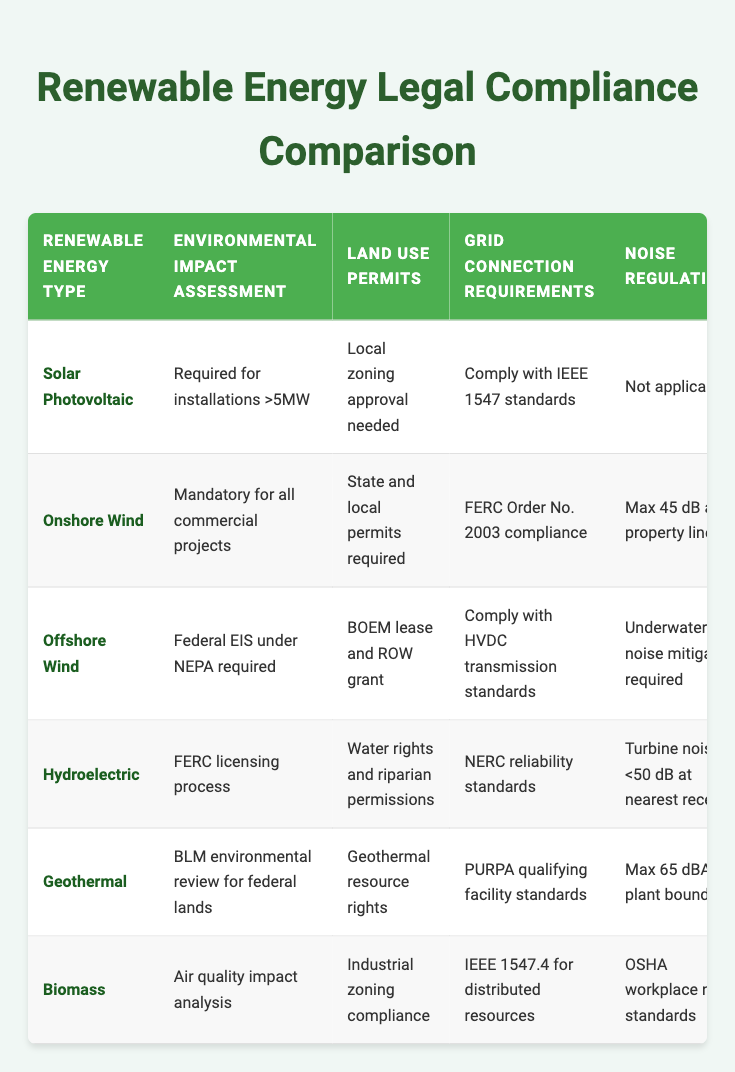What is the environmental impact assessment requirement for offshore wind installations? The table indicates that offshore wind installations require a federal Environmental Impact Statement (EIS) under the National Environmental Policy Act (NEPA).
Answer: Federal EIS under NEPA required Do biomass projects require a visual impact assessment? Looking at the table, biomass projects do require a visual impact assessment, but only for structures that exceed local height limits.
Answer: Yes Which renewable energy type requires a bird-friendly panel design? From the table, it is clear that solar photovoltaic installations are required to incorporate bird-friendly panel design as part of their wildlife protection measures.
Answer: Solar Photovoltaic What are the grid connection requirements for geothermal energy installations? The table shows that geothermal energy installations must comply with the Public Utility Regulatory Policies Act (PURPA) qualifying facility standards as their grid connection requirements.
Answer: PURPA qualifying facility standards Which renewable energy type has the strictest noise regulation? By examining the table, it's observed that onshore wind energy has a maximum allowable noise level of 45 dB at the property line, which is the strictest compared to the other renewable energy types listed.
Answer: Onshore Wind How many renewable energy types require an environmental impact assessment? The table lists six renewable energy types: solar photovoltaic, onshore wind, offshore wind, hydroelectric, geothermal, and biomass. Only biomass does not require an environmental impact assessment. Thus, five out of six require one.
Answer: 5 Is a decommissioning plan required for all renewable energy types? Reviewing the table, it is evident that all listed renewable energy types have a requirement for a decommissioning plan, indicating that the answer is affirmative.
Answer: Yes Which two renewable energy types require a visual impact assessment for their projects? The table states that both offshore wind and hydroelectric projects need a visual impact assessment. Offshore wind requires a visual impact analysis from shore, while hydroelectric requires one specifically for new dams.
Answer: Offshore Wind, Hydroelectric When comparing onshore wind and biomass, which has a stricter noise regulation? The table indicates that onshore wind has a maximum noise level of 45 dB at the property line, while biomass must comply with OSHA workplace noise standards. OSHA does not specify a strict dB limit here, so 45 dB is stricter.
Answer: Onshore Wind 